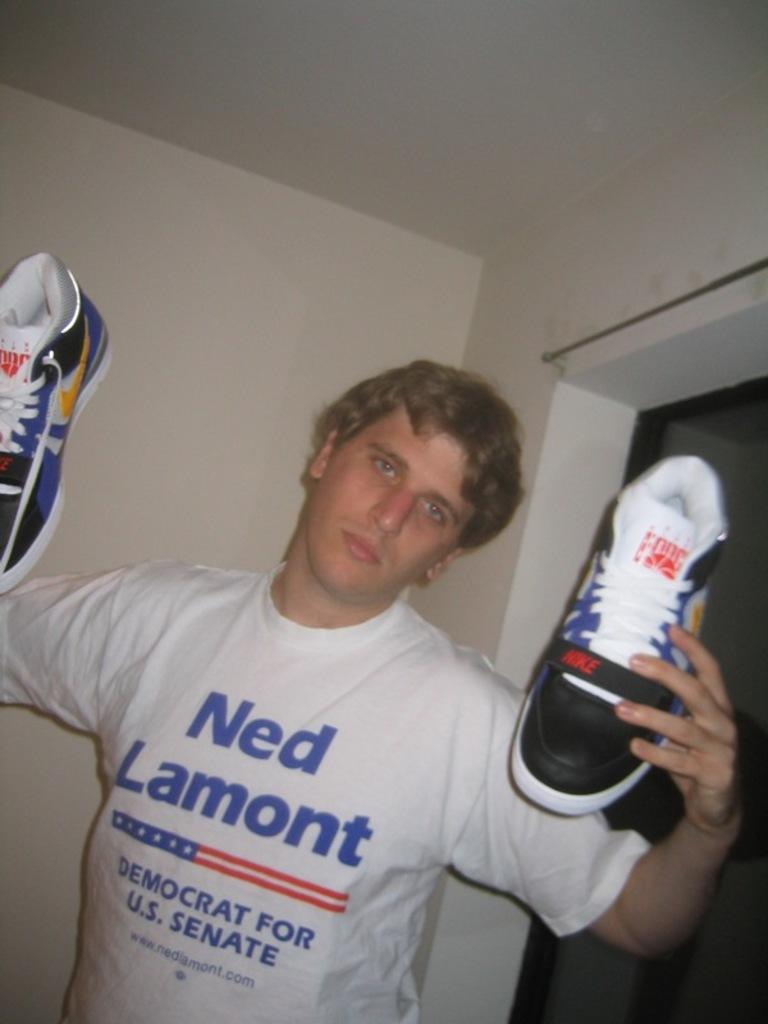<image>
Summarize the visual content of the image. The man is a supporter of Ned Lamont, Democrat for US Senate. 